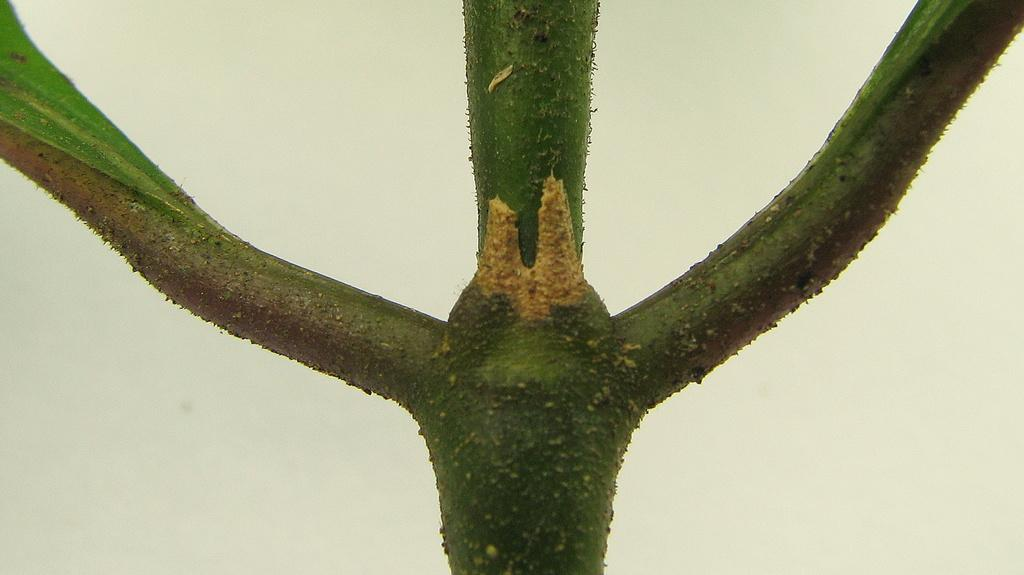What is present in the image? There is a plant in the image. What color is the background of the image? The background of the image is white. Can you see a rat drinking soda in the image? No, there is no rat or soda present in the image. 